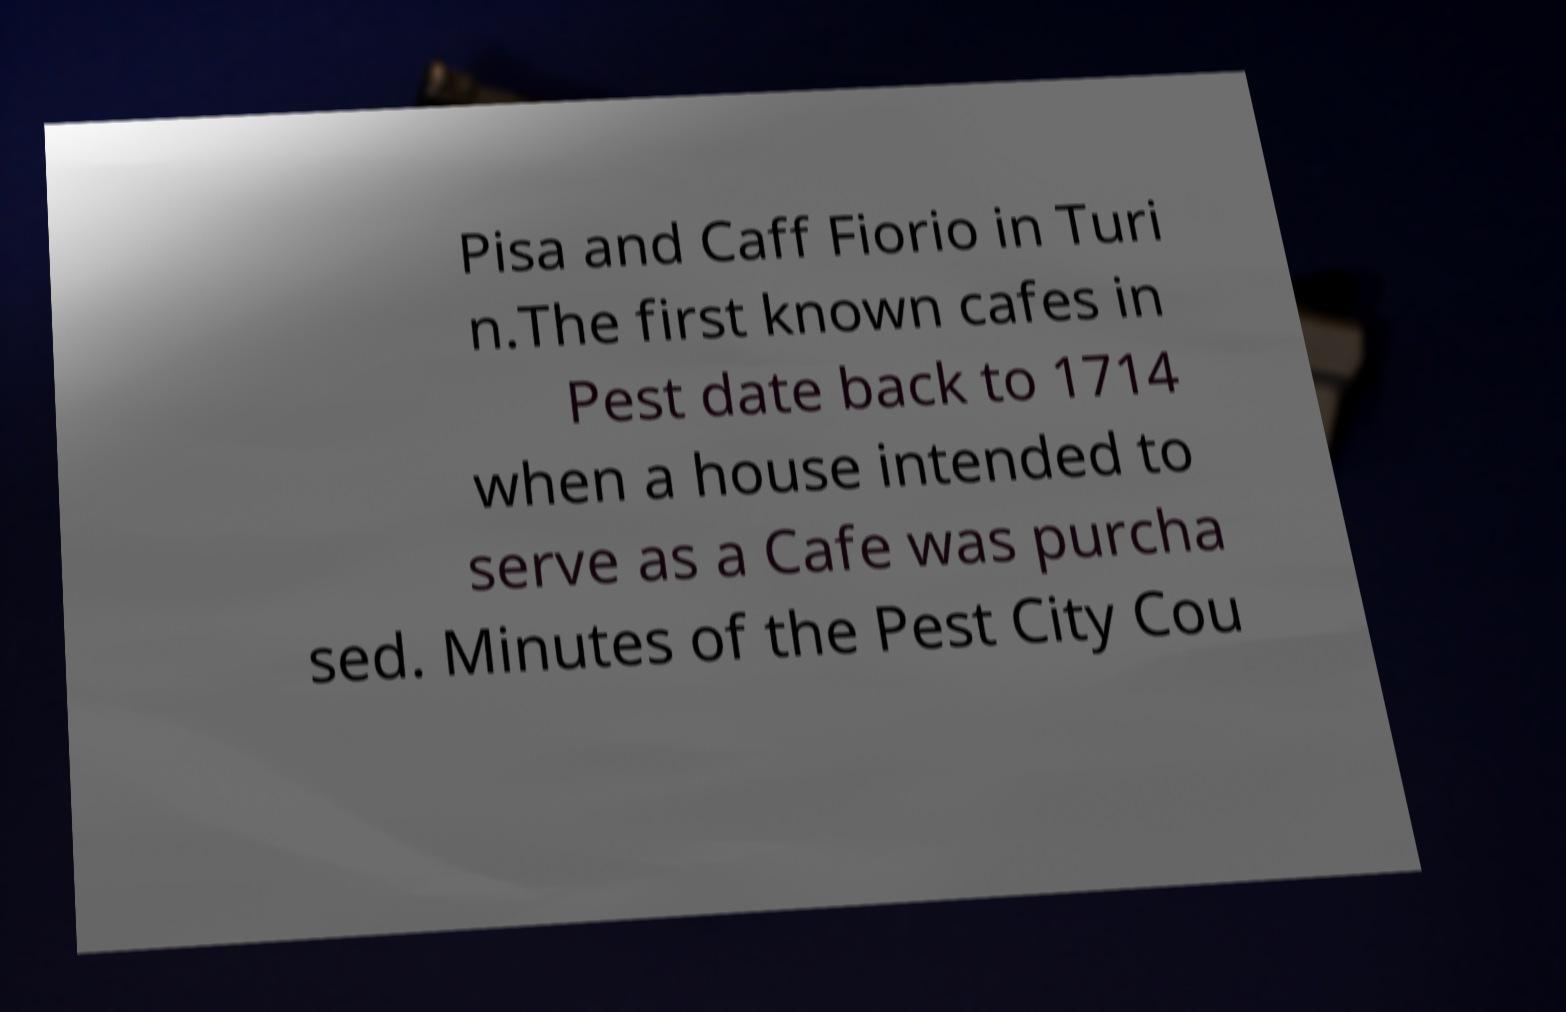Could you assist in decoding the text presented in this image and type it out clearly? Pisa and Caff Fiorio in Turi n.The first known cafes in Pest date back to 1714 when a house intended to serve as a Cafe was purcha sed. Minutes of the Pest City Cou 